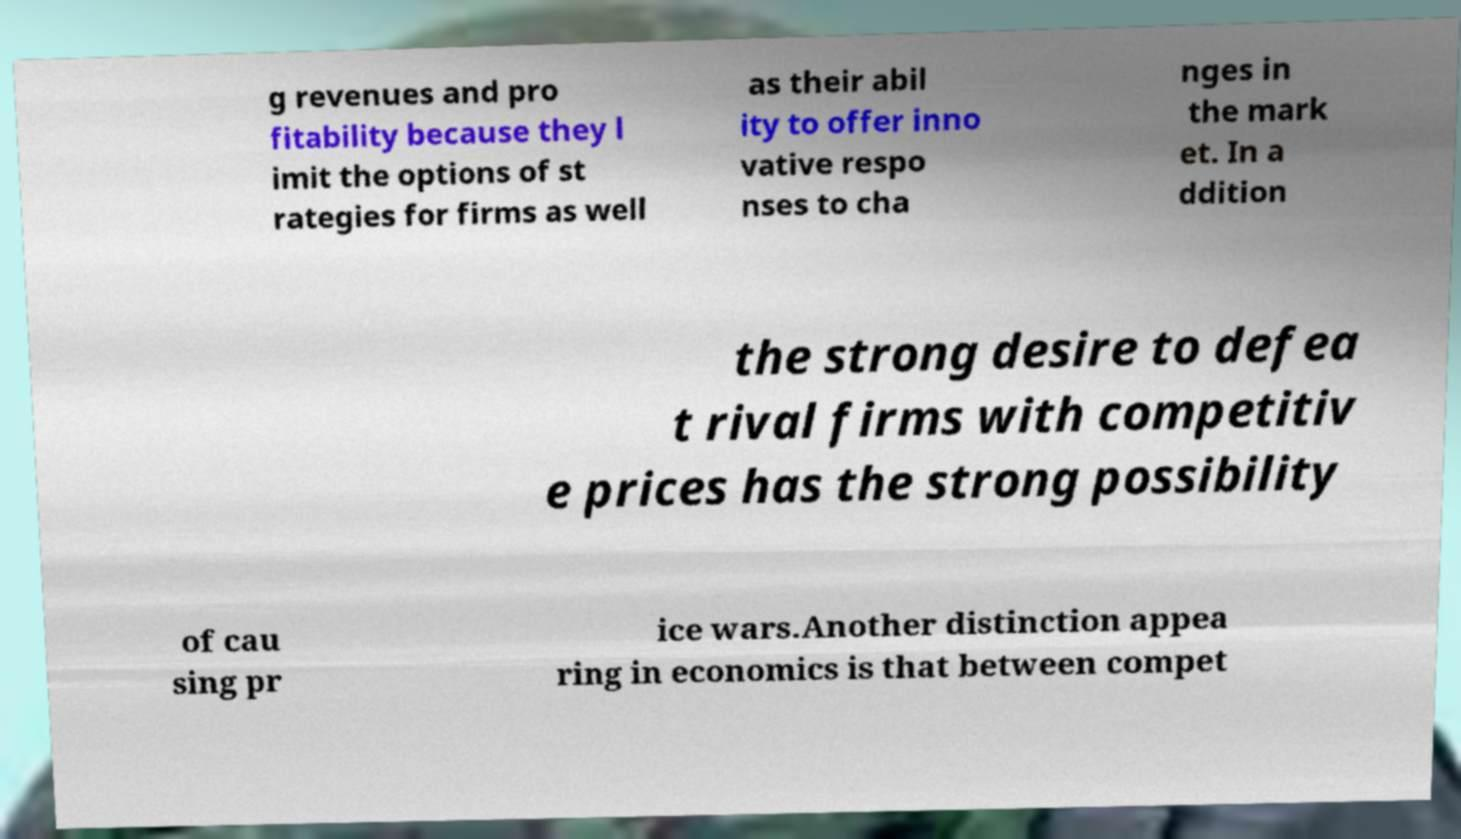Can you accurately transcribe the text from the provided image for me? g revenues and pro fitability because they l imit the options of st rategies for firms as well as their abil ity to offer inno vative respo nses to cha nges in the mark et. In a ddition the strong desire to defea t rival firms with competitiv e prices has the strong possibility of cau sing pr ice wars.Another distinction appea ring in economics is that between compet 